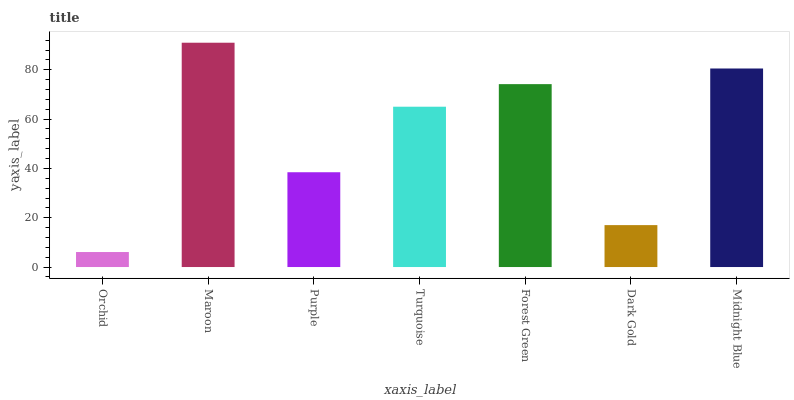Is Orchid the minimum?
Answer yes or no. Yes. Is Maroon the maximum?
Answer yes or no. Yes. Is Purple the minimum?
Answer yes or no. No. Is Purple the maximum?
Answer yes or no. No. Is Maroon greater than Purple?
Answer yes or no. Yes. Is Purple less than Maroon?
Answer yes or no. Yes. Is Purple greater than Maroon?
Answer yes or no. No. Is Maroon less than Purple?
Answer yes or no. No. Is Turquoise the high median?
Answer yes or no. Yes. Is Turquoise the low median?
Answer yes or no. Yes. Is Midnight Blue the high median?
Answer yes or no. No. Is Dark Gold the low median?
Answer yes or no. No. 